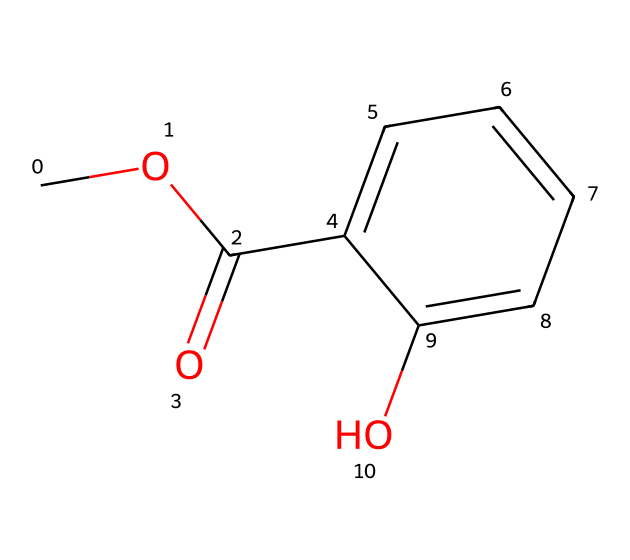What is the name of this chemical? The SMILES representation provided for the chemical indicates it has a methyl group (CO) attached to a salicylate structure, which is recognized as methyl salicylate.
Answer: methyl salicylate How many carbon atoms are in this chemical? By interpreting the SMILES notation, one can see that there are 9 carbon atoms present in the structure: 7 from the aromatic ring and 2 from the ester functional group.
Answer: 9 What type of bond connects the carbonyl carbon to the oxygen in the ester group? In the ester functional group (-COO-), the connection between the carbonyl carbon (C=O) and the oxygen (from -OCH3) is a single bond. Therefore, the bond type is a single bond.
Answer: single bond What is the functional group present in this molecule? Looking at the SMILES representation, the -COO- indicates the presence of an ester functional group in the molecule. The ester functional group characterizes this particular chemical.
Answer: ester Is methyl salicylate polar or nonpolar? The presence of the hydroxyl group (-OH) and the ester group contributes to polar characteristics, while the aromatic ring may introduce some nonpolarity. However, the overall molecule is considered polar due to the functional groups.
Answer: polar How many hydrogen atoms are in this chemical? Analyzing the chemical structure indicates there are 8 hydrogen atoms; each carbon bonds to hydrogen to fulfill its tetravalency in accordance with the structure's connectivity.
Answer: 8 What is the source of methyl salicylate commonly used in boat maintenance? Methyl salicylate is primarily derived from wintergreen oil, which is traditionally used in ointments and preservation techniques in boat maintenance due to its aromatic properties.
Answer: wintergreen oil 